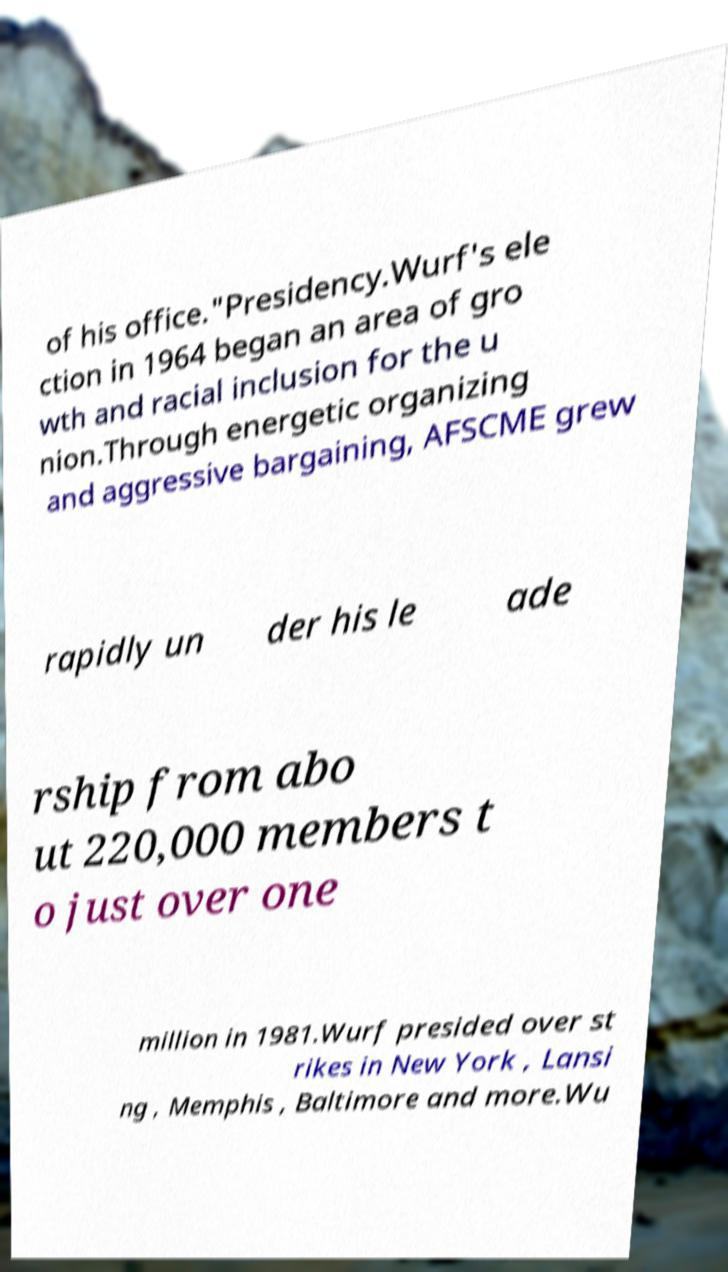For documentation purposes, I need the text within this image transcribed. Could you provide that? of his office."Presidency.Wurf's ele ction in 1964 began an area of gro wth and racial inclusion for the u nion.Through energetic organizing and aggressive bargaining, AFSCME grew rapidly un der his le ade rship from abo ut 220,000 members t o just over one million in 1981.Wurf presided over st rikes in New York , Lansi ng , Memphis , Baltimore and more.Wu 